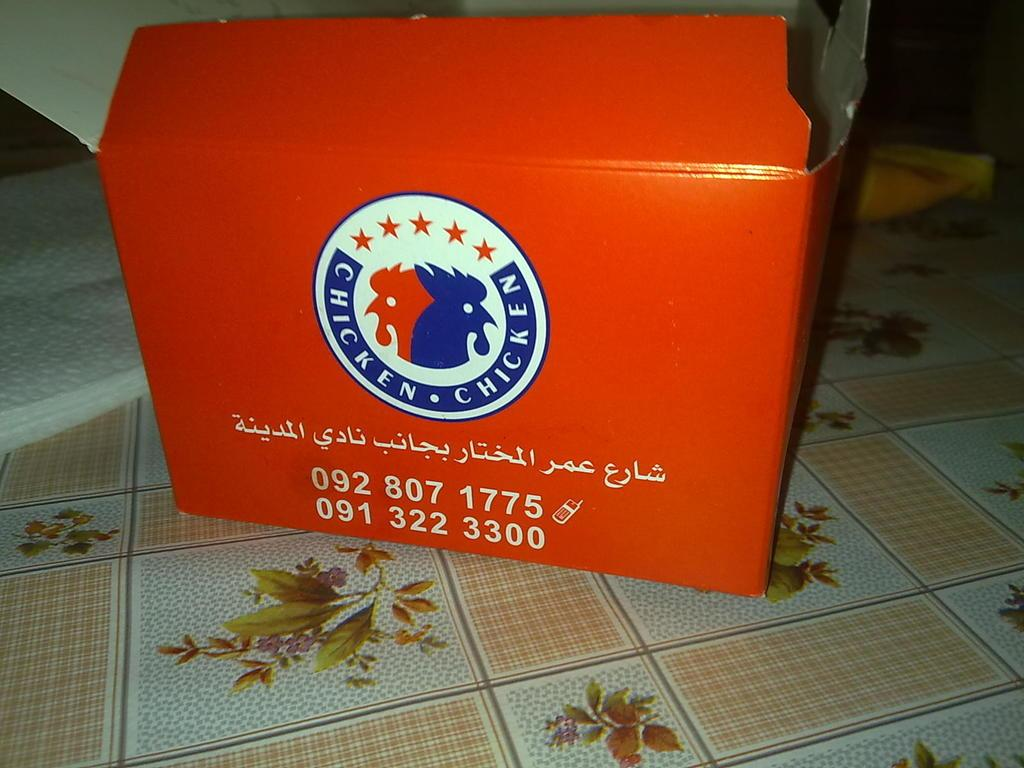<image>
Describe the image concisely. An orange book with numbers and Chicken Chicken logo. 